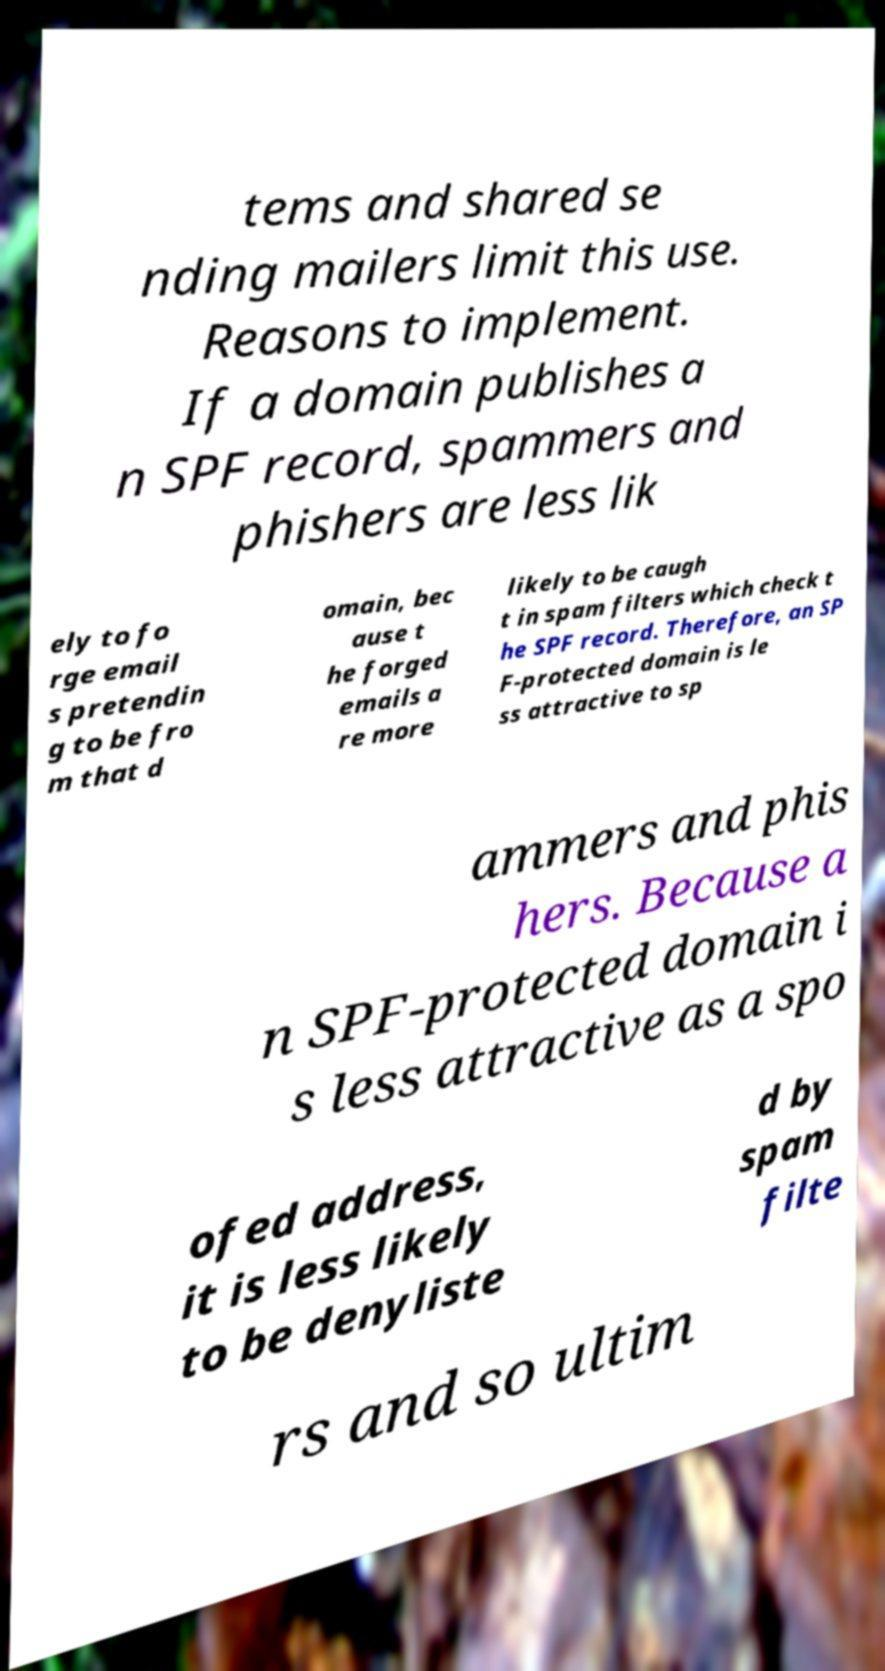Please read and relay the text visible in this image. What does it say? tems and shared se nding mailers limit this use. Reasons to implement. If a domain publishes a n SPF record, spammers and phishers are less lik ely to fo rge email s pretendin g to be fro m that d omain, bec ause t he forged emails a re more likely to be caugh t in spam filters which check t he SPF record. Therefore, an SP F-protected domain is le ss attractive to sp ammers and phis hers. Because a n SPF-protected domain i s less attractive as a spo ofed address, it is less likely to be denyliste d by spam filte rs and so ultim 